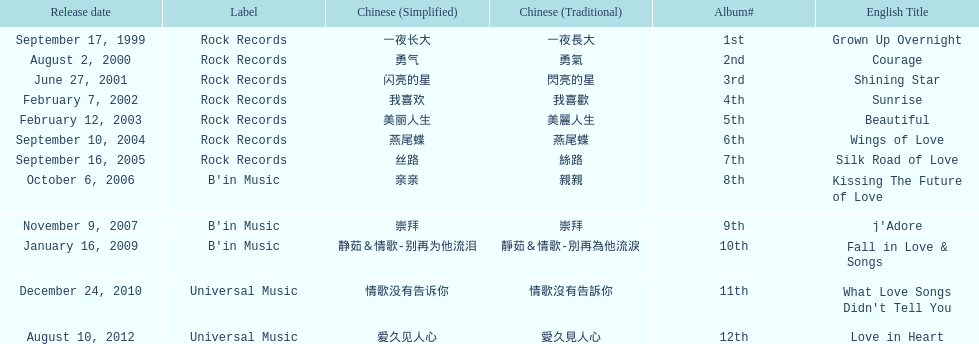What label was she working with before universal music? B'in Music. 